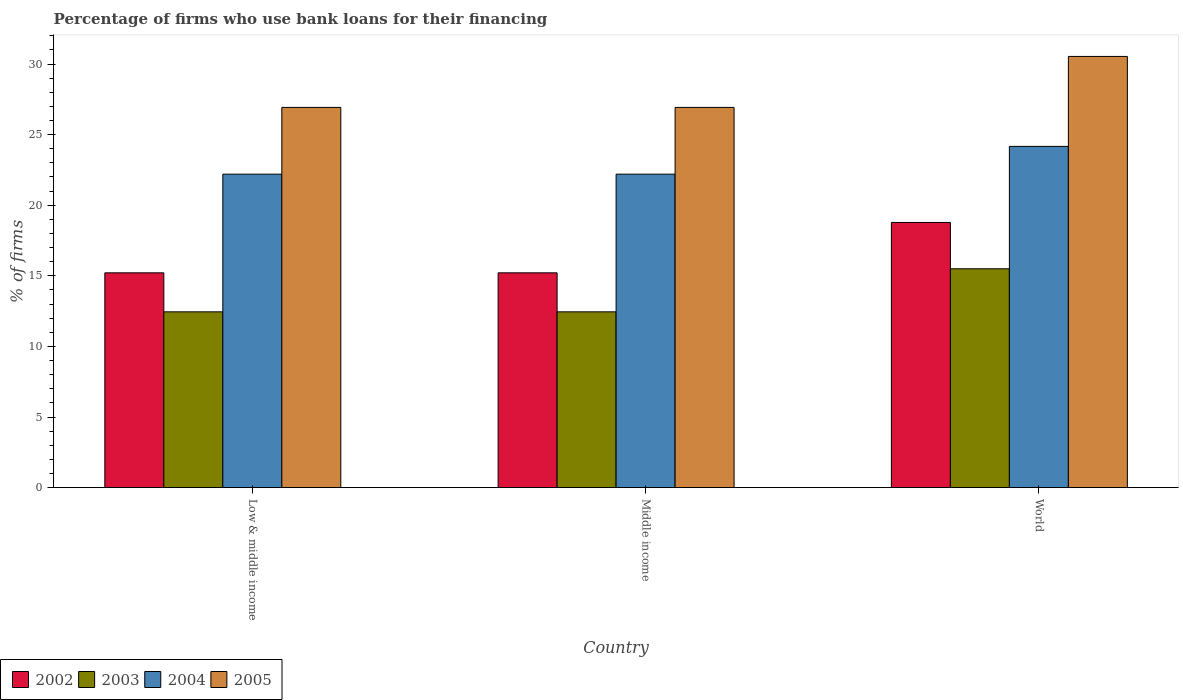How many different coloured bars are there?
Your answer should be compact. 4. How many groups of bars are there?
Your answer should be very brief. 3. How many bars are there on the 1st tick from the left?
Provide a short and direct response. 4. How many bars are there on the 2nd tick from the right?
Offer a terse response. 4. Across all countries, what is the maximum percentage of firms who use bank loans for their financing in 2003?
Your answer should be compact. 15.5. Across all countries, what is the minimum percentage of firms who use bank loans for their financing in 2004?
Offer a very short reply. 22.2. What is the total percentage of firms who use bank loans for their financing in 2003 in the graph?
Offer a very short reply. 40.4. What is the difference between the percentage of firms who use bank loans for their financing in 2002 in Middle income and that in World?
Keep it short and to the point. -3.57. What is the difference between the percentage of firms who use bank loans for their financing in 2002 in Low & middle income and the percentage of firms who use bank loans for their financing in 2004 in Middle income?
Your response must be concise. -6.99. What is the average percentage of firms who use bank loans for their financing in 2005 per country?
Ensure brevity in your answer.  28.13. What is the difference between the percentage of firms who use bank loans for their financing of/in 2003 and percentage of firms who use bank loans for their financing of/in 2002 in World?
Your answer should be very brief. -3.28. What is the ratio of the percentage of firms who use bank loans for their financing in 2003 in Low & middle income to that in World?
Provide a short and direct response. 0.8. Is the percentage of firms who use bank loans for their financing in 2003 in Low & middle income less than that in Middle income?
Your answer should be compact. No. What is the difference between the highest and the second highest percentage of firms who use bank loans for their financing in 2002?
Your answer should be very brief. 3.57. What is the difference between the highest and the lowest percentage of firms who use bank loans for their financing in 2003?
Make the answer very short. 3.05. What does the 1st bar from the right in Middle income represents?
Offer a very short reply. 2005. Is it the case that in every country, the sum of the percentage of firms who use bank loans for their financing in 2004 and percentage of firms who use bank loans for their financing in 2002 is greater than the percentage of firms who use bank loans for their financing in 2005?
Your answer should be very brief. Yes. How many bars are there?
Give a very brief answer. 12. Are all the bars in the graph horizontal?
Give a very brief answer. No. How many countries are there in the graph?
Ensure brevity in your answer.  3. What is the difference between two consecutive major ticks on the Y-axis?
Provide a short and direct response. 5. Are the values on the major ticks of Y-axis written in scientific E-notation?
Your answer should be compact. No. Does the graph contain any zero values?
Offer a terse response. No. Where does the legend appear in the graph?
Provide a succinct answer. Bottom left. How are the legend labels stacked?
Provide a short and direct response. Horizontal. What is the title of the graph?
Provide a short and direct response. Percentage of firms who use bank loans for their financing. What is the label or title of the Y-axis?
Make the answer very short. % of firms. What is the % of firms in 2002 in Low & middle income?
Give a very brief answer. 15.21. What is the % of firms of 2003 in Low & middle income?
Your answer should be very brief. 12.45. What is the % of firms in 2005 in Low & middle income?
Keep it short and to the point. 26.93. What is the % of firms in 2002 in Middle income?
Your answer should be very brief. 15.21. What is the % of firms in 2003 in Middle income?
Ensure brevity in your answer.  12.45. What is the % of firms of 2004 in Middle income?
Your response must be concise. 22.2. What is the % of firms of 2005 in Middle income?
Your answer should be very brief. 26.93. What is the % of firms in 2002 in World?
Give a very brief answer. 18.78. What is the % of firms of 2004 in World?
Provide a succinct answer. 24.17. What is the % of firms of 2005 in World?
Your answer should be very brief. 30.54. Across all countries, what is the maximum % of firms in 2002?
Keep it short and to the point. 18.78. Across all countries, what is the maximum % of firms of 2004?
Your response must be concise. 24.17. Across all countries, what is the maximum % of firms of 2005?
Provide a succinct answer. 30.54. Across all countries, what is the minimum % of firms in 2002?
Your answer should be compact. 15.21. Across all countries, what is the minimum % of firms in 2003?
Give a very brief answer. 12.45. Across all countries, what is the minimum % of firms of 2004?
Offer a terse response. 22.2. Across all countries, what is the minimum % of firms of 2005?
Provide a short and direct response. 26.93. What is the total % of firms of 2002 in the graph?
Your response must be concise. 49.21. What is the total % of firms of 2003 in the graph?
Ensure brevity in your answer.  40.4. What is the total % of firms in 2004 in the graph?
Provide a short and direct response. 68.57. What is the total % of firms in 2005 in the graph?
Your response must be concise. 84.39. What is the difference between the % of firms of 2002 in Low & middle income and that in World?
Provide a short and direct response. -3.57. What is the difference between the % of firms in 2003 in Low & middle income and that in World?
Offer a very short reply. -3.05. What is the difference between the % of firms in 2004 in Low & middle income and that in World?
Provide a succinct answer. -1.97. What is the difference between the % of firms of 2005 in Low & middle income and that in World?
Offer a terse response. -3.61. What is the difference between the % of firms of 2002 in Middle income and that in World?
Offer a terse response. -3.57. What is the difference between the % of firms of 2003 in Middle income and that in World?
Provide a short and direct response. -3.05. What is the difference between the % of firms in 2004 in Middle income and that in World?
Give a very brief answer. -1.97. What is the difference between the % of firms in 2005 in Middle income and that in World?
Your answer should be very brief. -3.61. What is the difference between the % of firms in 2002 in Low & middle income and the % of firms in 2003 in Middle income?
Your answer should be very brief. 2.76. What is the difference between the % of firms in 2002 in Low & middle income and the % of firms in 2004 in Middle income?
Offer a terse response. -6.99. What is the difference between the % of firms in 2002 in Low & middle income and the % of firms in 2005 in Middle income?
Ensure brevity in your answer.  -11.72. What is the difference between the % of firms of 2003 in Low & middle income and the % of firms of 2004 in Middle income?
Ensure brevity in your answer.  -9.75. What is the difference between the % of firms in 2003 in Low & middle income and the % of firms in 2005 in Middle income?
Give a very brief answer. -14.48. What is the difference between the % of firms in 2004 in Low & middle income and the % of firms in 2005 in Middle income?
Provide a short and direct response. -4.73. What is the difference between the % of firms of 2002 in Low & middle income and the % of firms of 2003 in World?
Your answer should be compact. -0.29. What is the difference between the % of firms in 2002 in Low & middle income and the % of firms in 2004 in World?
Offer a terse response. -8.95. What is the difference between the % of firms of 2002 in Low & middle income and the % of firms of 2005 in World?
Your answer should be very brief. -15.33. What is the difference between the % of firms of 2003 in Low & middle income and the % of firms of 2004 in World?
Ensure brevity in your answer.  -11.72. What is the difference between the % of firms of 2003 in Low & middle income and the % of firms of 2005 in World?
Give a very brief answer. -18.09. What is the difference between the % of firms in 2004 in Low & middle income and the % of firms in 2005 in World?
Ensure brevity in your answer.  -8.34. What is the difference between the % of firms in 2002 in Middle income and the % of firms in 2003 in World?
Make the answer very short. -0.29. What is the difference between the % of firms in 2002 in Middle income and the % of firms in 2004 in World?
Keep it short and to the point. -8.95. What is the difference between the % of firms of 2002 in Middle income and the % of firms of 2005 in World?
Keep it short and to the point. -15.33. What is the difference between the % of firms in 2003 in Middle income and the % of firms in 2004 in World?
Provide a short and direct response. -11.72. What is the difference between the % of firms of 2003 in Middle income and the % of firms of 2005 in World?
Make the answer very short. -18.09. What is the difference between the % of firms in 2004 in Middle income and the % of firms in 2005 in World?
Your answer should be very brief. -8.34. What is the average % of firms in 2002 per country?
Keep it short and to the point. 16.4. What is the average % of firms of 2003 per country?
Your answer should be very brief. 13.47. What is the average % of firms in 2004 per country?
Your answer should be very brief. 22.86. What is the average % of firms in 2005 per country?
Give a very brief answer. 28.13. What is the difference between the % of firms of 2002 and % of firms of 2003 in Low & middle income?
Keep it short and to the point. 2.76. What is the difference between the % of firms of 2002 and % of firms of 2004 in Low & middle income?
Make the answer very short. -6.99. What is the difference between the % of firms in 2002 and % of firms in 2005 in Low & middle income?
Give a very brief answer. -11.72. What is the difference between the % of firms in 2003 and % of firms in 2004 in Low & middle income?
Make the answer very short. -9.75. What is the difference between the % of firms in 2003 and % of firms in 2005 in Low & middle income?
Offer a very short reply. -14.48. What is the difference between the % of firms of 2004 and % of firms of 2005 in Low & middle income?
Make the answer very short. -4.73. What is the difference between the % of firms in 2002 and % of firms in 2003 in Middle income?
Ensure brevity in your answer.  2.76. What is the difference between the % of firms in 2002 and % of firms in 2004 in Middle income?
Offer a terse response. -6.99. What is the difference between the % of firms of 2002 and % of firms of 2005 in Middle income?
Ensure brevity in your answer.  -11.72. What is the difference between the % of firms in 2003 and % of firms in 2004 in Middle income?
Ensure brevity in your answer.  -9.75. What is the difference between the % of firms of 2003 and % of firms of 2005 in Middle income?
Provide a short and direct response. -14.48. What is the difference between the % of firms of 2004 and % of firms of 2005 in Middle income?
Keep it short and to the point. -4.73. What is the difference between the % of firms of 2002 and % of firms of 2003 in World?
Offer a terse response. 3.28. What is the difference between the % of firms in 2002 and % of firms in 2004 in World?
Your response must be concise. -5.39. What is the difference between the % of firms of 2002 and % of firms of 2005 in World?
Provide a short and direct response. -11.76. What is the difference between the % of firms of 2003 and % of firms of 2004 in World?
Your answer should be compact. -8.67. What is the difference between the % of firms of 2003 and % of firms of 2005 in World?
Offer a very short reply. -15.04. What is the difference between the % of firms of 2004 and % of firms of 2005 in World?
Give a very brief answer. -6.37. What is the ratio of the % of firms in 2002 in Low & middle income to that in Middle income?
Offer a very short reply. 1. What is the ratio of the % of firms in 2003 in Low & middle income to that in Middle income?
Your response must be concise. 1. What is the ratio of the % of firms of 2004 in Low & middle income to that in Middle income?
Provide a succinct answer. 1. What is the ratio of the % of firms in 2005 in Low & middle income to that in Middle income?
Ensure brevity in your answer.  1. What is the ratio of the % of firms of 2002 in Low & middle income to that in World?
Keep it short and to the point. 0.81. What is the ratio of the % of firms in 2003 in Low & middle income to that in World?
Keep it short and to the point. 0.8. What is the ratio of the % of firms in 2004 in Low & middle income to that in World?
Provide a succinct answer. 0.92. What is the ratio of the % of firms in 2005 in Low & middle income to that in World?
Give a very brief answer. 0.88. What is the ratio of the % of firms of 2002 in Middle income to that in World?
Give a very brief answer. 0.81. What is the ratio of the % of firms in 2003 in Middle income to that in World?
Keep it short and to the point. 0.8. What is the ratio of the % of firms of 2004 in Middle income to that in World?
Your response must be concise. 0.92. What is the ratio of the % of firms in 2005 in Middle income to that in World?
Make the answer very short. 0.88. What is the difference between the highest and the second highest % of firms of 2002?
Your answer should be very brief. 3.57. What is the difference between the highest and the second highest % of firms in 2003?
Make the answer very short. 3.05. What is the difference between the highest and the second highest % of firms in 2004?
Provide a short and direct response. 1.97. What is the difference between the highest and the second highest % of firms in 2005?
Your answer should be compact. 3.61. What is the difference between the highest and the lowest % of firms in 2002?
Ensure brevity in your answer.  3.57. What is the difference between the highest and the lowest % of firms of 2003?
Ensure brevity in your answer.  3.05. What is the difference between the highest and the lowest % of firms of 2004?
Your answer should be compact. 1.97. What is the difference between the highest and the lowest % of firms of 2005?
Keep it short and to the point. 3.61. 